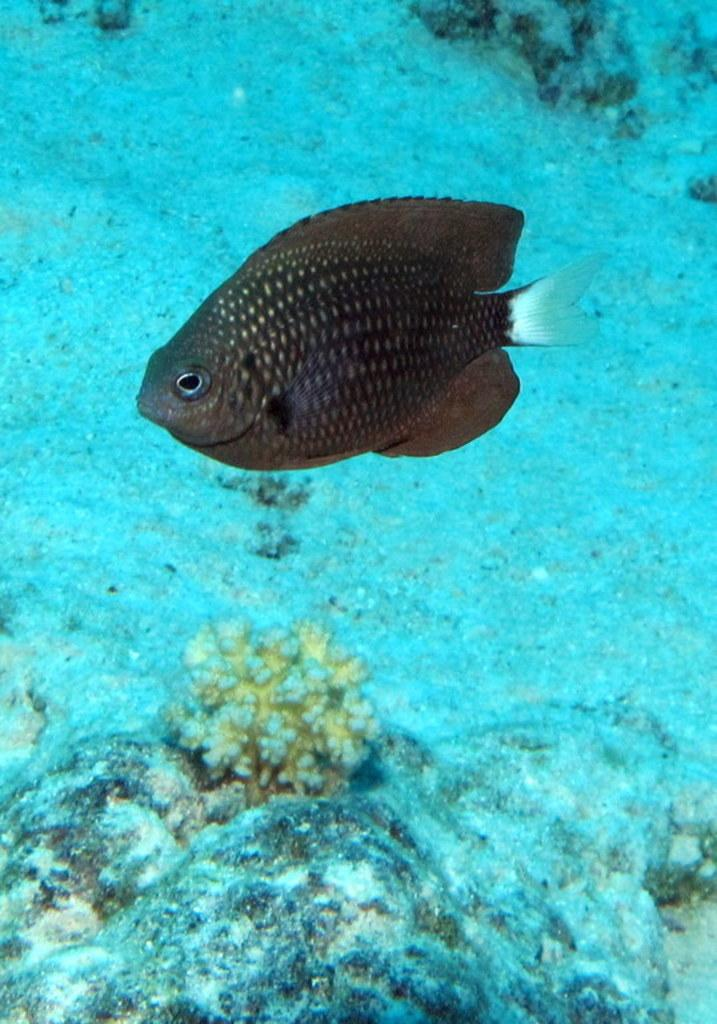What type of animal can be seen in the water in the image? There is a fish in the water in the image. What can be found at the bottom of the water? There are stones at the bottom of the water in the image. Are there any plants visible in the water? Yes, there is a plant in the water in the image. What type of material is present in the water? There is sand in the water in the image. How many clocks can be seen hanging on the plant in the image? There are no clocks present in the image, and the plant is not mentioned as having any clocks hanging on it. 